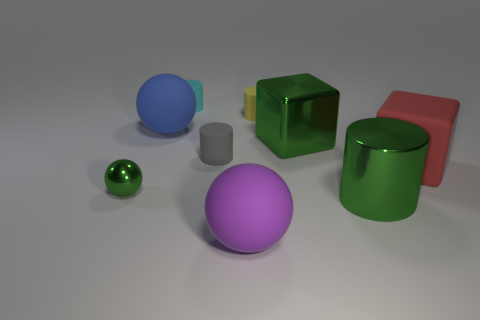Subtract all purple cylinders. Subtract all purple spheres. How many cylinders are left? 4 Add 1 large purple rubber cylinders. How many objects exist? 10 Subtract all cylinders. How many objects are left? 5 Subtract 0 cyan spheres. How many objects are left? 9 Subtract all big green matte spheres. Subtract all big red matte objects. How many objects are left? 8 Add 7 cyan cylinders. How many cyan cylinders are left? 8 Add 3 red blocks. How many red blocks exist? 4 